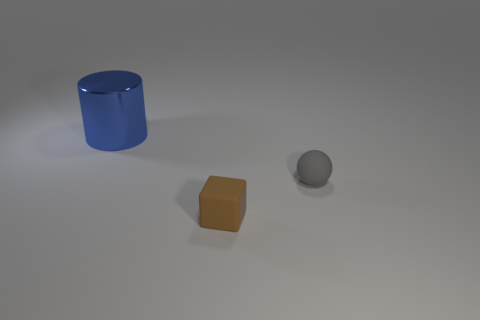What is the color of the largest object, and what shape does it have? The largest object in the image is a cylinder, and it has a glossy blue surface. 